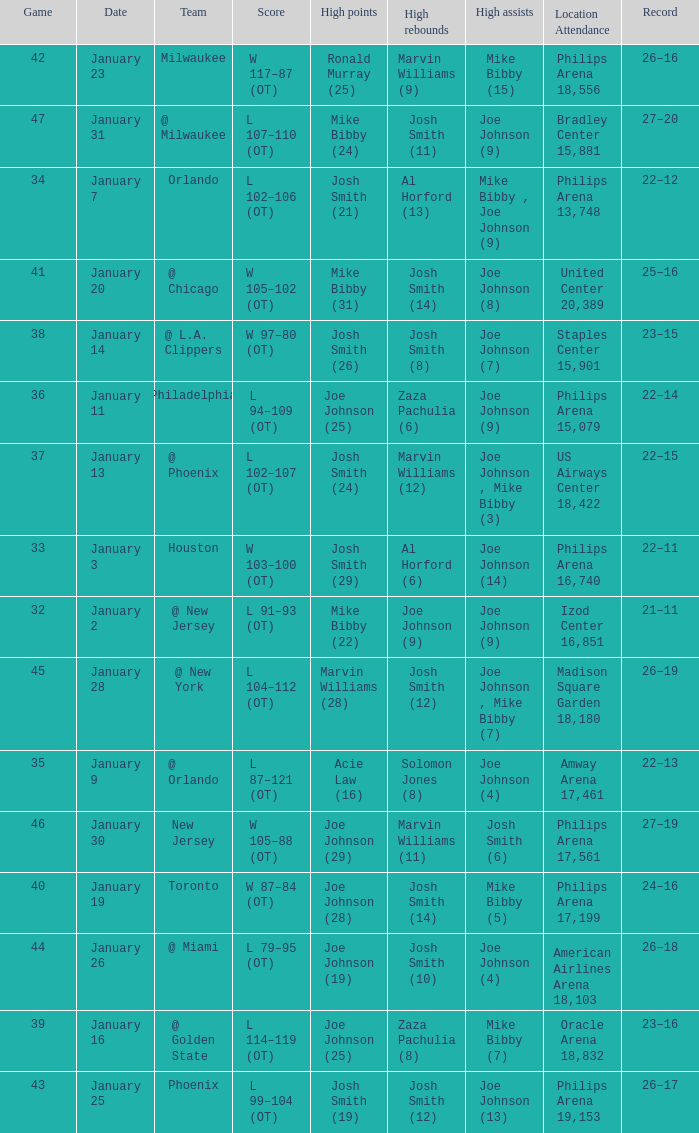Which date was game 35 on? January 9. 